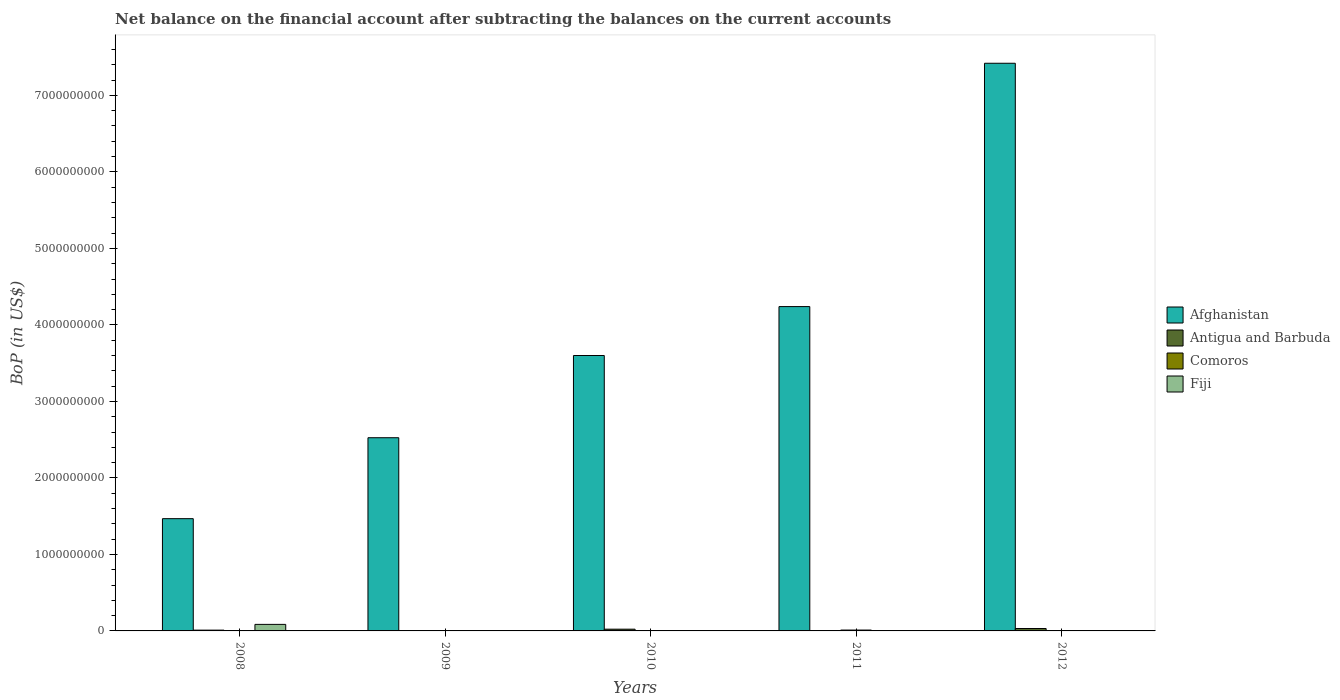Are the number of bars on each tick of the X-axis equal?
Offer a terse response. No. How many bars are there on the 5th tick from the left?
Ensure brevity in your answer.  3. How many bars are there on the 4th tick from the right?
Give a very brief answer. 2. What is the label of the 5th group of bars from the left?
Your answer should be very brief. 2012. In how many cases, is the number of bars for a given year not equal to the number of legend labels?
Provide a succinct answer. 5. What is the Balance of Payments in Comoros in 2008?
Your response must be concise. 0. Across all years, what is the maximum Balance of Payments in Afghanistan?
Give a very brief answer. 7.42e+09. Across all years, what is the minimum Balance of Payments in Afghanistan?
Provide a short and direct response. 1.47e+09. What is the total Balance of Payments in Antigua and Barbuda in the graph?
Your response must be concise. 6.48e+07. What is the difference between the Balance of Payments in Afghanistan in 2009 and that in 2011?
Provide a succinct answer. -1.71e+09. What is the difference between the Balance of Payments in Antigua and Barbuda in 2011 and the Balance of Payments in Comoros in 2012?
Offer a terse response. -1.39e+06. What is the average Balance of Payments in Comoros per year?
Your answer should be compact. 4.05e+06. In the year 2012, what is the difference between the Balance of Payments in Comoros and Balance of Payments in Antigua and Barbuda?
Give a very brief answer. -3.01e+07. What is the ratio of the Balance of Payments in Afghanistan in 2008 to that in 2011?
Offer a terse response. 0.35. Is the Balance of Payments in Afghanistan in 2010 less than that in 2011?
Keep it short and to the point. Yes. What is the difference between the highest and the second highest Balance of Payments in Antigua and Barbuda?
Offer a very short reply. 8.69e+06. What is the difference between the highest and the lowest Balance of Payments in Fiji?
Your answer should be very brief. 8.55e+07. In how many years, is the Balance of Payments in Antigua and Barbuda greater than the average Balance of Payments in Antigua and Barbuda taken over all years?
Offer a terse response. 2. Is the sum of the Balance of Payments in Antigua and Barbuda in 2008 and 2012 greater than the maximum Balance of Payments in Afghanistan across all years?
Offer a very short reply. No. Is it the case that in every year, the sum of the Balance of Payments in Afghanistan and Balance of Payments in Comoros is greater than the Balance of Payments in Antigua and Barbuda?
Provide a succinct answer. Yes. Are all the bars in the graph horizontal?
Make the answer very short. No. What is the difference between two consecutive major ticks on the Y-axis?
Keep it short and to the point. 1.00e+09. Are the values on the major ticks of Y-axis written in scientific E-notation?
Offer a very short reply. No. Does the graph contain any zero values?
Provide a short and direct response. Yes. Does the graph contain grids?
Your answer should be compact. No. How many legend labels are there?
Provide a short and direct response. 4. How are the legend labels stacked?
Offer a terse response. Vertical. What is the title of the graph?
Provide a short and direct response. Net balance on the financial account after subtracting the balances on the current accounts. What is the label or title of the X-axis?
Give a very brief answer. Years. What is the label or title of the Y-axis?
Give a very brief answer. BoP (in US$). What is the BoP (in US$) of Afghanistan in 2008?
Your answer should be very brief. 1.47e+09. What is the BoP (in US$) of Antigua and Barbuda in 2008?
Your answer should be compact. 1.04e+07. What is the BoP (in US$) of Fiji in 2008?
Provide a succinct answer. 8.55e+07. What is the BoP (in US$) of Afghanistan in 2009?
Your answer should be compact. 2.53e+09. What is the BoP (in US$) of Comoros in 2009?
Offer a terse response. 4.08e+06. What is the BoP (in US$) in Afghanistan in 2010?
Offer a very short reply. 3.60e+09. What is the BoP (in US$) in Antigua and Barbuda in 2010?
Keep it short and to the point. 2.28e+07. What is the BoP (in US$) in Comoros in 2010?
Offer a very short reply. 3.42e+06. What is the BoP (in US$) in Fiji in 2010?
Your answer should be compact. 0. What is the BoP (in US$) of Afghanistan in 2011?
Ensure brevity in your answer.  4.24e+09. What is the BoP (in US$) in Antigua and Barbuda in 2011?
Offer a very short reply. 0. What is the BoP (in US$) of Comoros in 2011?
Offer a very short reply. 1.13e+07. What is the BoP (in US$) of Afghanistan in 2012?
Your answer should be compact. 7.42e+09. What is the BoP (in US$) in Antigua and Barbuda in 2012?
Give a very brief answer. 3.15e+07. What is the BoP (in US$) in Comoros in 2012?
Your response must be concise. 1.39e+06. What is the BoP (in US$) of Fiji in 2012?
Provide a short and direct response. 0. Across all years, what is the maximum BoP (in US$) of Afghanistan?
Make the answer very short. 7.42e+09. Across all years, what is the maximum BoP (in US$) in Antigua and Barbuda?
Offer a terse response. 3.15e+07. Across all years, what is the maximum BoP (in US$) of Comoros?
Keep it short and to the point. 1.13e+07. Across all years, what is the maximum BoP (in US$) in Fiji?
Provide a short and direct response. 8.55e+07. Across all years, what is the minimum BoP (in US$) in Afghanistan?
Give a very brief answer. 1.47e+09. Across all years, what is the minimum BoP (in US$) in Antigua and Barbuda?
Your answer should be very brief. 0. Across all years, what is the minimum BoP (in US$) in Comoros?
Make the answer very short. 0. Across all years, what is the minimum BoP (in US$) in Fiji?
Make the answer very short. 0. What is the total BoP (in US$) in Afghanistan in the graph?
Provide a short and direct response. 1.93e+1. What is the total BoP (in US$) in Antigua and Barbuda in the graph?
Provide a short and direct response. 6.48e+07. What is the total BoP (in US$) of Comoros in the graph?
Keep it short and to the point. 2.02e+07. What is the total BoP (in US$) in Fiji in the graph?
Offer a terse response. 8.55e+07. What is the difference between the BoP (in US$) of Afghanistan in 2008 and that in 2009?
Give a very brief answer. -1.06e+09. What is the difference between the BoP (in US$) of Afghanistan in 2008 and that in 2010?
Provide a short and direct response. -2.13e+09. What is the difference between the BoP (in US$) of Antigua and Barbuda in 2008 and that in 2010?
Keep it short and to the point. -1.24e+07. What is the difference between the BoP (in US$) of Afghanistan in 2008 and that in 2011?
Offer a terse response. -2.77e+09. What is the difference between the BoP (in US$) of Afghanistan in 2008 and that in 2012?
Give a very brief answer. -5.95e+09. What is the difference between the BoP (in US$) of Antigua and Barbuda in 2008 and that in 2012?
Keep it short and to the point. -2.11e+07. What is the difference between the BoP (in US$) of Afghanistan in 2009 and that in 2010?
Provide a succinct answer. -1.07e+09. What is the difference between the BoP (in US$) in Comoros in 2009 and that in 2010?
Your answer should be very brief. 6.61e+05. What is the difference between the BoP (in US$) in Afghanistan in 2009 and that in 2011?
Ensure brevity in your answer.  -1.71e+09. What is the difference between the BoP (in US$) in Comoros in 2009 and that in 2011?
Give a very brief answer. -7.27e+06. What is the difference between the BoP (in US$) in Afghanistan in 2009 and that in 2012?
Your answer should be compact. -4.89e+09. What is the difference between the BoP (in US$) in Comoros in 2009 and that in 2012?
Make the answer very short. 2.69e+06. What is the difference between the BoP (in US$) of Afghanistan in 2010 and that in 2011?
Your answer should be very brief. -6.39e+08. What is the difference between the BoP (in US$) in Comoros in 2010 and that in 2011?
Ensure brevity in your answer.  -7.93e+06. What is the difference between the BoP (in US$) in Afghanistan in 2010 and that in 2012?
Your response must be concise. -3.82e+09. What is the difference between the BoP (in US$) of Antigua and Barbuda in 2010 and that in 2012?
Your response must be concise. -8.69e+06. What is the difference between the BoP (in US$) of Comoros in 2010 and that in 2012?
Your answer should be very brief. 2.03e+06. What is the difference between the BoP (in US$) in Afghanistan in 2011 and that in 2012?
Offer a very short reply. -3.18e+09. What is the difference between the BoP (in US$) in Comoros in 2011 and that in 2012?
Make the answer very short. 9.95e+06. What is the difference between the BoP (in US$) in Afghanistan in 2008 and the BoP (in US$) in Comoros in 2009?
Offer a terse response. 1.46e+09. What is the difference between the BoP (in US$) of Antigua and Barbuda in 2008 and the BoP (in US$) of Comoros in 2009?
Ensure brevity in your answer.  6.32e+06. What is the difference between the BoP (in US$) of Afghanistan in 2008 and the BoP (in US$) of Antigua and Barbuda in 2010?
Give a very brief answer. 1.44e+09. What is the difference between the BoP (in US$) of Afghanistan in 2008 and the BoP (in US$) of Comoros in 2010?
Provide a succinct answer. 1.46e+09. What is the difference between the BoP (in US$) of Antigua and Barbuda in 2008 and the BoP (in US$) of Comoros in 2010?
Offer a terse response. 6.98e+06. What is the difference between the BoP (in US$) of Afghanistan in 2008 and the BoP (in US$) of Comoros in 2011?
Your response must be concise. 1.46e+09. What is the difference between the BoP (in US$) in Antigua and Barbuda in 2008 and the BoP (in US$) in Comoros in 2011?
Offer a terse response. -9.45e+05. What is the difference between the BoP (in US$) in Afghanistan in 2008 and the BoP (in US$) in Antigua and Barbuda in 2012?
Offer a terse response. 1.44e+09. What is the difference between the BoP (in US$) of Afghanistan in 2008 and the BoP (in US$) of Comoros in 2012?
Your answer should be compact. 1.47e+09. What is the difference between the BoP (in US$) of Antigua and Barbuda in 2008 and the BoP (in US$) of Comoros in 2012?
Provide a succinct answer. 9.01e+06. What is the difference between the BoP (in US$) in Afghanistan in 2009 and the BoP (in US$) in Antigua and Barbuda in 2010?
Offer a very short reply. 2.50e+09. What is the difference between the BoP (in US$) in Afghanistan in 2009 and the BoP (in US$) in Comoros in 2010?
Provide a succinct answer. 2.52e+09. What is the difference between the BoP (in US$) in Afghanistan in 2009 and the BoP (in US$) in Comoros in 2011?
Ensure brevity in your answer.  2.51e+09. What is the difference between the BoP (in US$) in Afghanistan in 2009 and the BoP (in US$) in Antigua and Barbuda in 2012?
Give a very brief answer. 2.49e+09. What is the difference between the BoP (in US$) of Afghanistan in 2009 and the BoP (in US$) of Comoros in 2012?
Keep it short and to the point. 2.52e+09. What is the difference between the BoP (in US$) of Afghanistan in 2010 and the BoP (in US$) of Comoros in 2011?
Offer a very short reply. 3.59e+09. What is the difference between the BoP (in US$) of Antigua and Barbuda in 2010 and the BoP (in US$) of Comoros in 2011?
Make the answer very short. 1.15e+07. What is the difference between the BoP (in US$) in Afghanistan in 2010 and the BoP (in US$) in Antigua and Barbuda in 2012?
Provide a short and direct response. 3.57e+09. What is the difference between the BoP (in US$) of Afghanistan in 2010 and the BoP (in US$) of Comoros in 2012?
Ensure brevity in your answer.  3.60e+09. What is the difference between the BoP (in US$) in Antigua and Barbuda in 2010 and the BoP (in US$) in Comoros in 2012?
Offer a terse response. 2.15e+07. What is the difference between the BoP (in US$) of Afghanistan in 2011 and the BoP (in US$) of Antigua and Barbuda in 2012?
Offer a very short reply. 4.21e+09. What is the difference between the BoP (in US$) in Afghanistan in 2011 and the BoP (in US$) in Comoros in 2012?
Provide a succinct answer. 4.24e+09. What is the average BoP (in US$) of Afghanistan per year?
Provide a short and direct response. 3.85e+09. What is the average BoP (in US$) in Antigua and Barbuda per year?
Your answer should be very brief. 1.30e+07. What is the average BoP (in US$) of Comoros per year?
Provide a short and direct response. 4.05e+06. What is the average BoP (in US$) of Fiji per year?
Give a very brief answer. 1.71e+07. In the year 2008, what is the difference between the BoP (in US$) in Afghanistan and BoP (in US$) in Antigua and Barbuda?
Provide a succinct answer. 1.46e+09. In the year 2008, what is the difference between the BoP (in US$) of Afghanistan and BoP (in US$) of Fiji?
Ensure brevity in your answer.  1.38e+09. In the year 2008, what is the difference between the BoP (in US$) in Antigua and Barbuda and BoP (in US$) in Fiji?
Offer a terse response. -7.51e+07. In the year 2009, what is the difference between the BoP (in US$) of Afghanistan and BoP (in US$) of Comoros?
Offer a terse response. 2.52e+09. In the year 2010, what is the difference between the BoP (in US$) in Afghanistan and BoP (in US$) in Antigua and Barbuda?
Your answer should be very brief. 3.58e+09. In the year 2010, what is the difference between the BoP (in US$) in Afghanistan and BoP (in US$) in Comoros?
Give a very brief answer. 3.60e+09. In the year 2010, what is the difference between the BoP (in US$) in Antigua and Barbuda and BoP (in US$) in Comoros?
Offer a very short reply. 1.94e+07. In the year 2011, what is the difference between the BoP (in US$) of Afghanistan and BoP (in US$) of Comoros?
Provide a succinct answer. 4.23e+09. In the year 2012, what is the difference between the BoP (in US$) of Afghanistan and BoP (in US$) of Antigua and Barbuda?
Your answer should be very brief. 7.39e+09. In the year 2012, what is the difference between the BoP (in US$) of Afghanistan and BoP (in US$) of Comoros?
Make the answer very short. 7.42e+09. In the year 2012, what is the difference between the BoP (in US$) of Antigua and Barbuda and BoP (in US$) of Comoros?
Provide a succinct answer. 3.01e+07. What is the ratio of the BoP (in US$) in Afghanistan in 2008 to that in 2009?
Make the answer very short. 0.58. What is the ratio of the BoP (in US$) in Afghanistan in 2008 to that in 2010?
Your response must be concise. 0.41. What is the ratio of the BoP (in US$) in Antigua and Barbuda in 2008 to that in 2010?
Ensure brevity in your answer.  0.46. What is the ratio of the BoP (in US$) of Afghanistan in 2008 to that in 2011?
Offer a very short reply. 0.35. What is the ratio of the BoP (in US$) of Afghanistan in 2008 to that in 2012?
Ensure brevity in your answer.  0.2. What is the ratio of the BoP (in US$) in Antigua and Barbuda in 2008 to that in 2012?
Ensure brevity in your answer.  0.33. What is the ratio of the BoP (in US$) of Afghanistan in 2009 to that in 2010?
Keep it short and to the point. 0.7. What is the ratio of the BoP (in US$) in Comoros in 2009 to that in 2010?
Make the answer very short. 1.19. What is the ratio of the BoP (in US$) in Afghanistan in 2009 to that in 2011?
Give a very brief answer. 0.6. What is the ratio of the BoP (in US$) of Comoros in 2009 to that in 2011?
Offer a terse response. 0.36. What is the ratio of the BoP (in US$) in Afghanistan in 2009 to that in 2012?
Provide a short and direct response. 0.34. What is the ratio of the BoP (in US$) in Comoros in 2009 to that in 2012?
Give a very brief answer. 2.93. What is the ratio of the BoP (in US$) in Afghanistan in 2010 to that in 2011?
Your response must be concise. 0.85. What is the ratio of the BoP (in US$) of Comoros in 2010 to that in 2011?
Ensure brevity in your answer.  0.3. What is the ratio of the BoP (in US$) of Afghanistan in 2010 to that in 2012?
Ensure brevity in your answer.  0.49. What is the ratio of the BoP (in US$) in Antigua and Barbuda in 2010 to that in 2012?
Offer a terse response. 0.72. What is the ratio of the BoP (in US$) of Comoros in 2010 to that in 2012?
Make the answer very short. 2.46. What is the ratio of the BoP (in US$) of Afghanistan in 2011 to that in 2012?
Ensure brevity in your answer.  0.57. What is the ratio of the BoP (in US$) of Comoros in 2011 to that in 2012?
Offer a very short reply. 8.15. What is the difference between the highest and the second highest BoP (in US$) in Afghanistan?
Your response must be concise. 3.18e+09. What is the difference between the highest and the second highest BoP (in US$) in Antigua and Barbuda?
Make the answer very short. 8.69e+06. What is the difference between the highest and the second highest BoP (in US$) in Comoros?
Your answer should be very brief. 7.27e+06. What is the difference between the highest and the lowest BoP (in US$) of Afghanistan?
Your response must be concise. 5.95e+09. What is the difference between the highest and the lowest BoP (in US$) of Antigua and Barbuda?
Your answer should be compact. 3.15e+07. What is the difference between the highest and the lowest BoP (in US$) of Comoros?
Offer a very short reply. 1.13e+07. What is the difference between the highest and the lowest BoP (in US$) in Fiji?
Make the answer very short. 8.55e+07. 